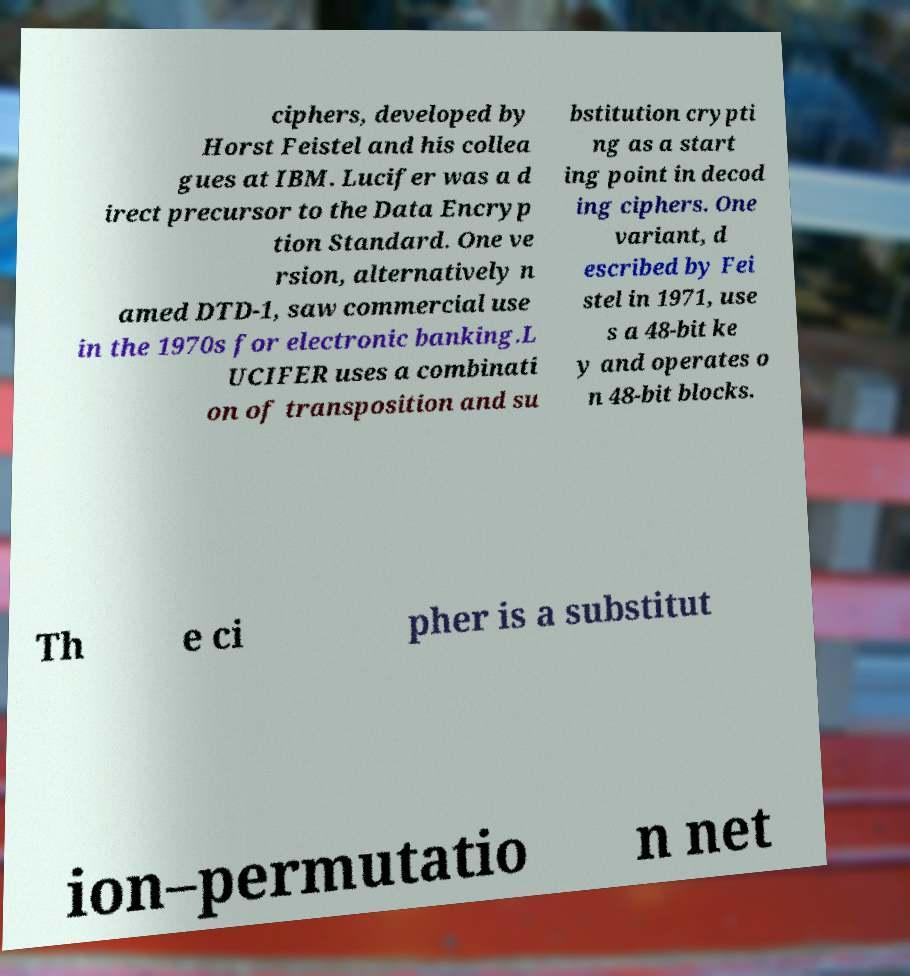What messages or text are displayed in this image? I need them in a readable, typed format. ciphers, developed by Horst Feistel and his collea gues at IBM. Lucifer was a d irect precursor to the Data Encryp tion Standard. One ve rsion, alternatively n amed DTD-1, saw commercial use in the 1970s for electronic banking.L UCIFER uses a combinati on of transposition and su bstitution crypti ng as a start ing point in decod ing ciphers. One variant, d escribed by Fei stel in 1971, use s a 48-bit ke y and operates o n 48-bit blocks. Th e ci pher is a substitut ion–permutatio n net 